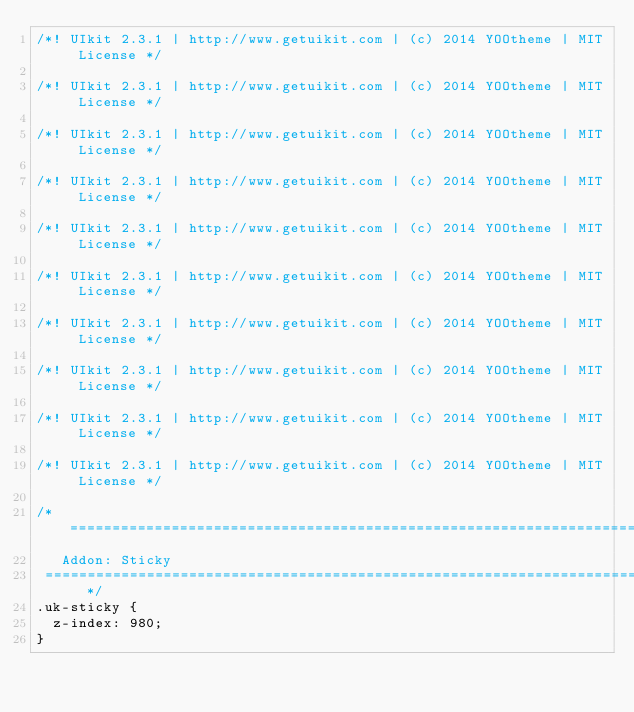Convert code to text. <code><loc_0><loc_0><loc_500><loc_500><_CSS_>/*! UIkit 2.3.1 | http://www.getuikit.com | (c) 2014 YOOtheme | MIT License */

/*! UIkit 2.3.1 | http://www.getuikit.com | (c) 2014 YOOtheme | MIT License */

/*! UIkit 2.3.1 | http://www.getuikit.com | (c) 2014 YOOtheme | MIT License */

/*! UIkit 2.3.1 | http://www.getuikit.com | (c) 2014 YOOtheme | MIT License */

/*! UIkit 2.3.1 | http://www.getuikit.com | (c) 2014 YOOtheme | MIT License */

/*! UIkit 2.3.1 | http://www.getuikit.com | (c) 2014 YOOtheme | MIT License */

/*! UIkit 2.3.1 | http://www.getuikit.com | (c) 2014 YOOtheme | MIT License */

/*! UIkit 2.3.1 | http://www.getuikit.com | (c) 2014 YOOtheme | MIT License */

/*! UIkit 2.3.1 | http://www.getuikit.com | (c) 2014 YOOtheme | MIT License */

/*! UIkit 2.3.1 | http://www.getuikit.com | (c) 2014 YOOtheme | MIT License */

/* ========================================================================
   Addon: Sticky
 ========================================================================== */
.uk-sticky {
  z-index: 980;
}
</code> 